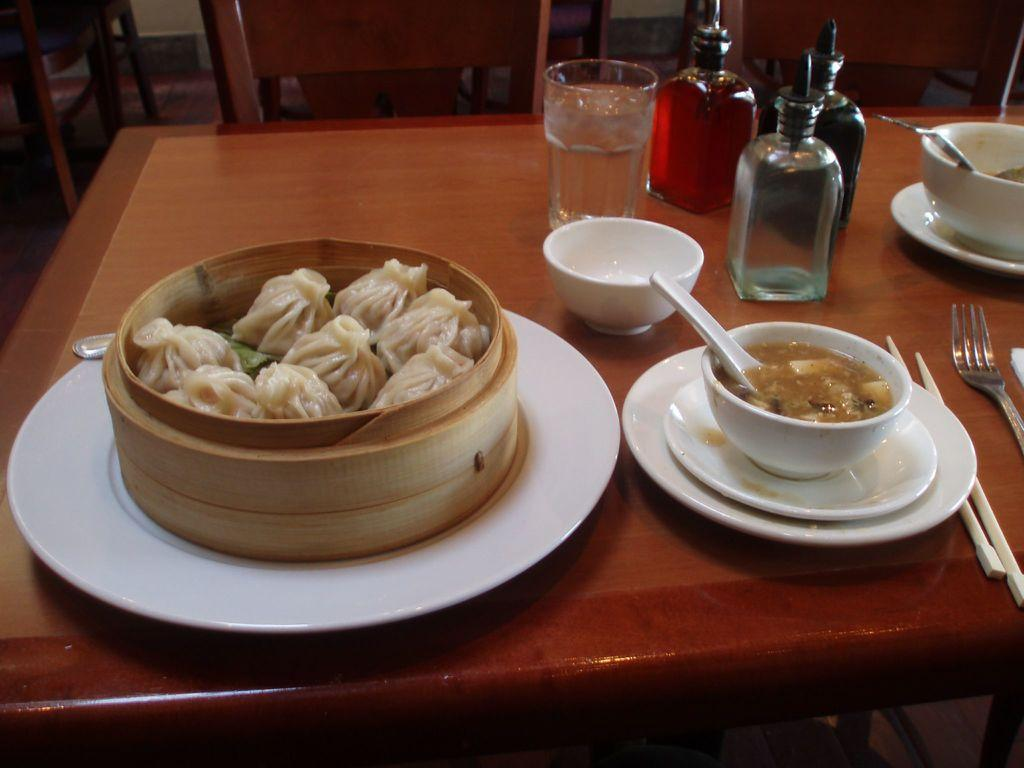What type of furniture is present in the image? There is a table and a chair in the image. What objects are on the table? There are bowls, plates, bottles, and forks on the table. What can be found inside the bowls and on the plates? There is food visible on the table, both in the bowls and on the plates. What type of chin is visible on the table in the image? There is no chin present in the image; it is a table with various objects on it. What channel is being watched on the television in the image? There is no television present in the image; it only features a table, chair, and various objects. 